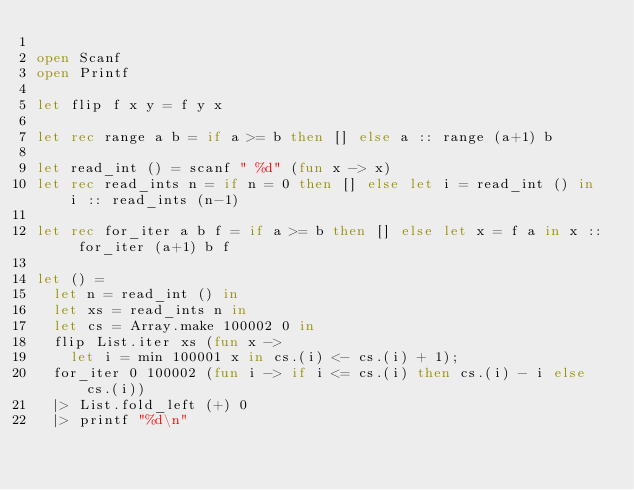Convert code to text. <code><loc_0><loc_0><loc_500><loc_500><_OCaml_>
open Scanf
open Printf

let flip f x y = f y x

let rec range a b = if a >= b then [] else a :: range (a+1) b

let read_int () = scanf " %d" (fun x -> x)
let rec read_ints n = if n = 0 then [] else let i = read_int () in i :: read_ints (n-1)

let rec for_iter a b f = if a >= b then [] else let x = f a in x :: for_iter (a+1) b f

let () =
  let n = read_int () in
  let xs = read_ints n in
  let cs = Array.make 100002 0 in
  flip List.iter xs (fun x ->
    let i = min 100001 x in cs.(i) <- cs.(i) + 1);
  for_iter 0 100002 (fun i -> if i <= cs.(i) then cs.(i) - i else cs.(i))
  |> List.fold_left (+) 0
  |> printf "%d\n"
</code> 